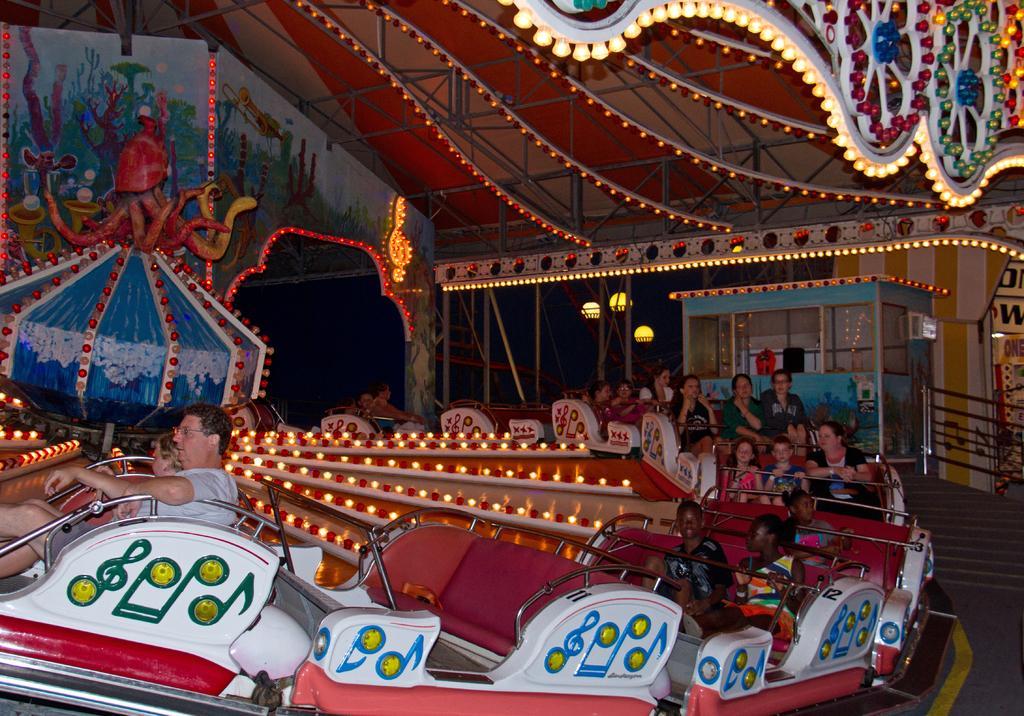Could you give a brief overview of what you see in this image? This is a picture taken in an exhibition. The picture consists of carousel, where people are sitting in seats. In the background there are lights and a room. At the top there are lights to the ceiling. 